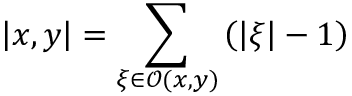<formula> <loc_0><loc_0><loc_500><loc_500>\left | x , y \right | = \sum _ { \xi \in \mathcal { O } ( x , y ) } \left ( \left | \xi \right | - 1 \right )</formula> 